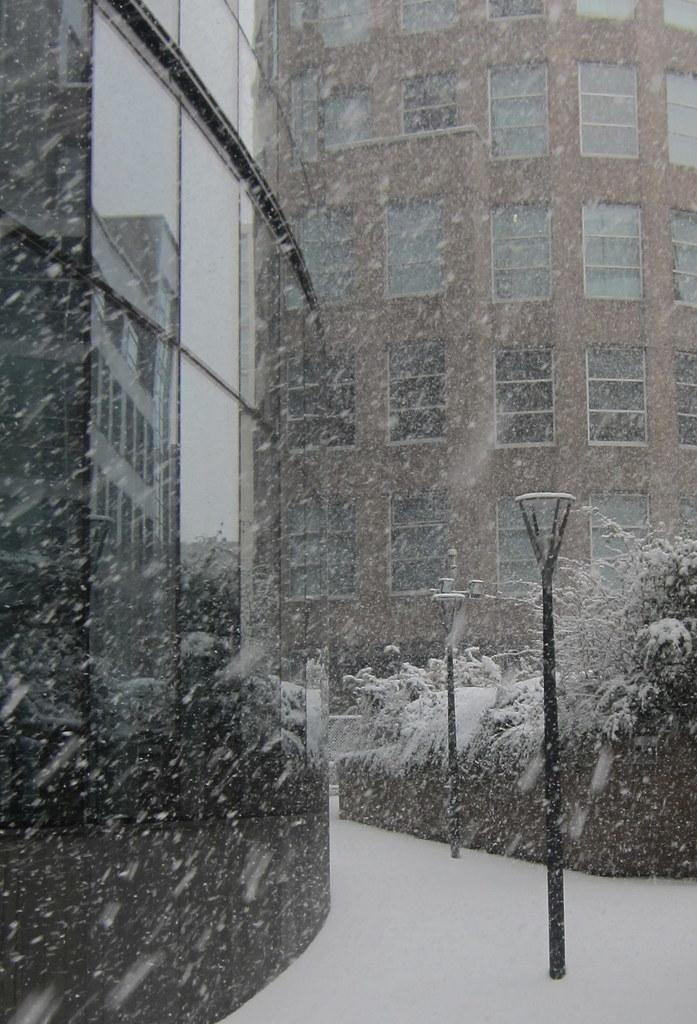What type of structures can be seen in the image? There are buildings in the image. What feature do the buildings have? The buildings have glass windows. What type of vegetation is present in the image? There are trees in the image. What type of lighting is present in the image? There are light poles in the image. What weather condition is depicted in the image? The image shows snow. Can you tell me the condition of the water in the image? There is no water present in the image; it shows snow instead. What type of sea creatures can be seen in the image? There are no sea creatures present in the image, as it does not depict a sea or ocean setting. 